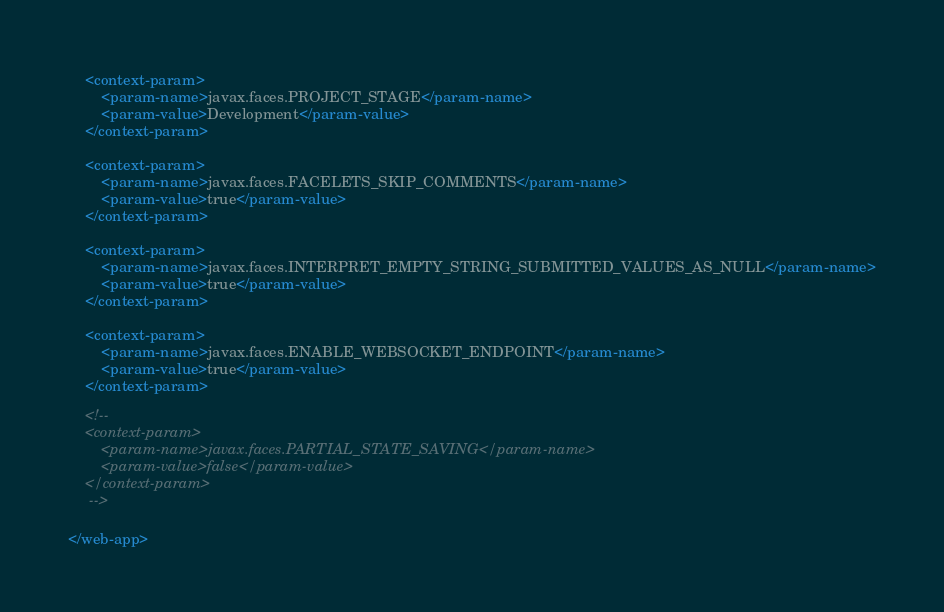Convert code to text. <code><loc_0><loc_0><loc_500><loc_500><_XML_>	<context-param>
		<param-name>javax.faces.PROJECT_STAGE</param-name>
		<param-value>Development</param-value>
	</context-param>

	<context-param>
		<param-name>javax.faces.FACELETS_SKIP_COMMENTS</param-name>
		<param-value>true</param-value>
	</context-param>

	<context-param>
		<param-name>javax.faces.INTERPRET_EMPTY_STRING_SUBMITTED_VALUES_AS_NULL</param-name>
		<param-value>true</param-value>
	</context-param>

	<context-param>
		<param-name>javax.faces.ENABLE_WEBSOCKET_ENDPOINT</param-name>
		<param-value>true</param-value>
	</context-param>

	<!-- 
	<context-param>
		<param-name>javax.faces.PARTIAL_STATE_SAVING</param-name>
		<param-value>false</param-value>
	</context-param>
	 -->
	 
</web-app></code> 